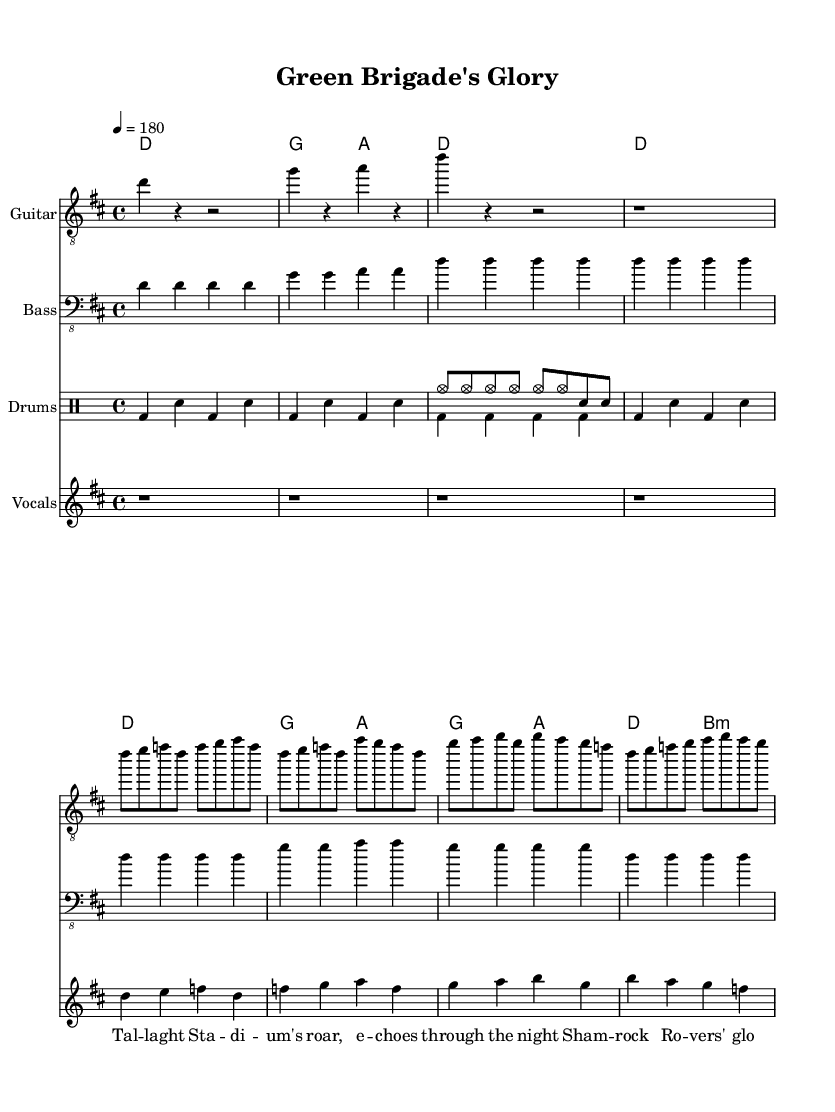What is the key signature of this music? The key signature is D major, which has two sharps (F# and C#). This is determined by looking at the `\key` command, which indicates the key being used throughout the piece.
Answer: D major What is the time signature of this music? The time signature is 4/4, also known as common time. This is specified by the `\time` command indicated at the beginning of the global section.
Answer: 4/4 What is the tempo marking of this music? The tempo marking is quarter note equals 180. This indicates how fast the piece should be played and can be found at the top of the score, under the `\tempo` command.
Answer: 180 How many measures are in the chorus section? There are four measures in the chorus section as indicated by the structure and notation following the chorus label in the electric guitar part.
Answer: 4 What is the main chord progression used in the verse? The main chord progression in the verse is D, G, A. This can be determined by looking at the `\chordmode` section where the chords are laid out for each measure corresponding to the verse lines.
Answer: D, G, A What is the rhythmic pattern played by the drums? The rhythmic pattern is a basic alternating kick drum and snare pattern. This is shown in the `\drummode`, which outlines the kick (bd) and snare (sn) notes played in four-beat measures with fills interspersed.
Answer: Alternating kick and snare What type of guitar clef is used in this music? The clef used for the guitar part is treble clef (8). This is noted in the `\clef` command associated with the guitar staff.
Answer: Treble clef 